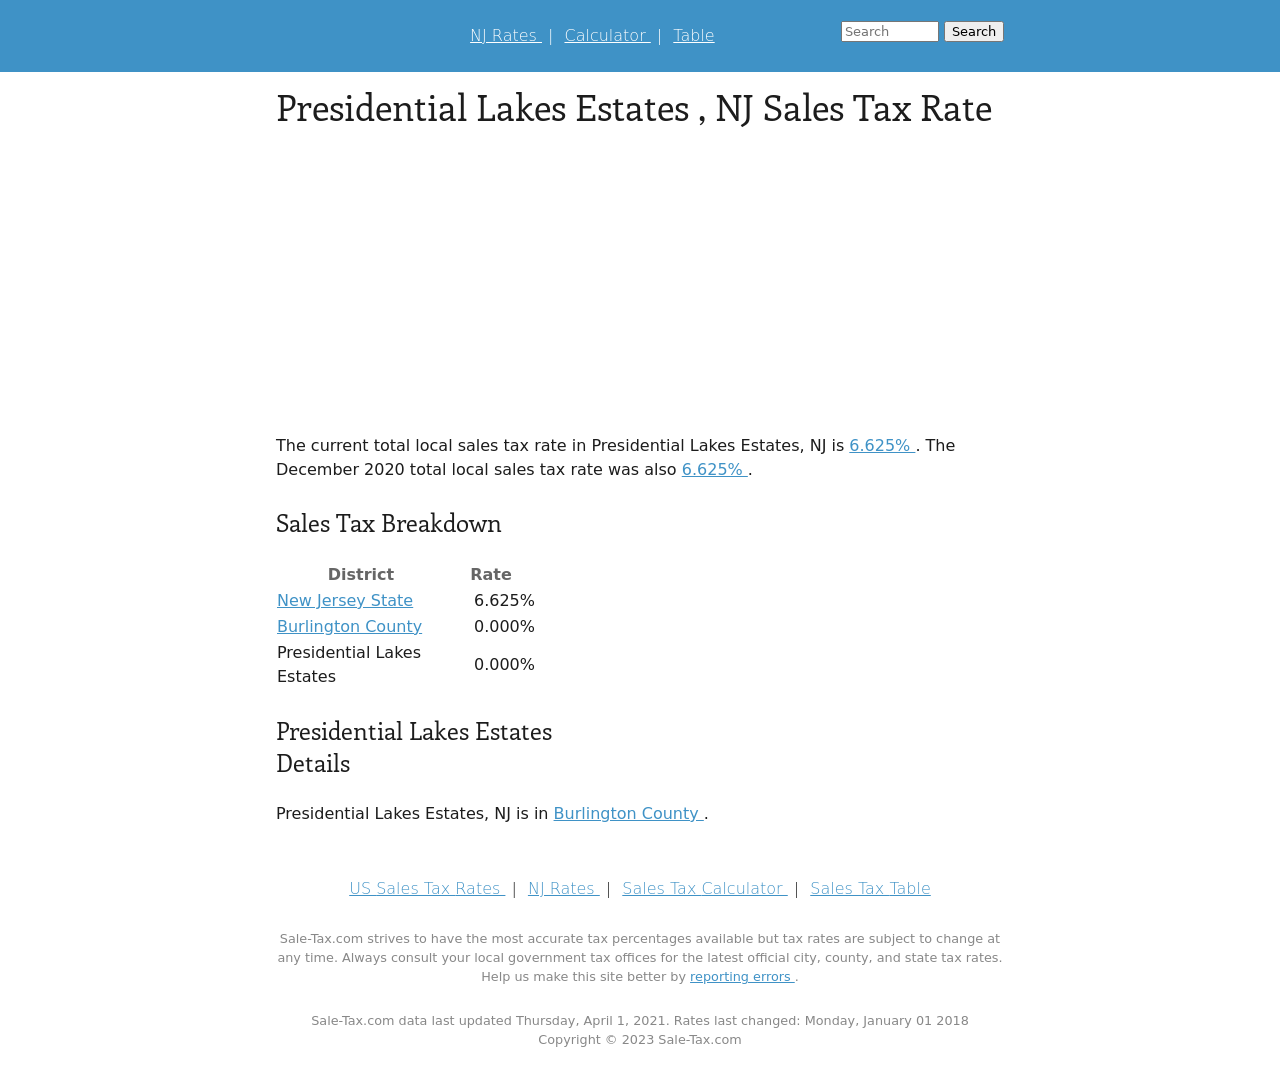How could a website design impact the perception of tax information displayed like in the image? Website design can greatly influence how users interpret and react to tax information. A clean, well-organized layout, like in the image, helps ensure the data is easy to read and understand. Effective design can mitigate confusion and build trust, encouraging users to rely on the site for accurate tax information which is critical given the financial and legal implications of tax rates. 